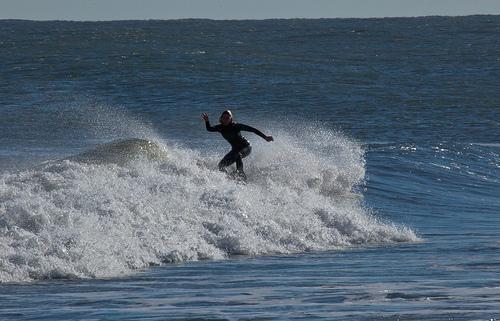How many people are pictured?
Give a very brief answer. 1. 